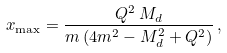<formula> <loc_0><loc_0><loc_500><loc_500>x _ { \max } = \frac { Q ^ { 2 } \, M _ { d } } { m \, ( 4 m ^ { 2 } - M _ { d } ^ { 2 } + Q ^ { 2 } ) } \, ,</formula> 